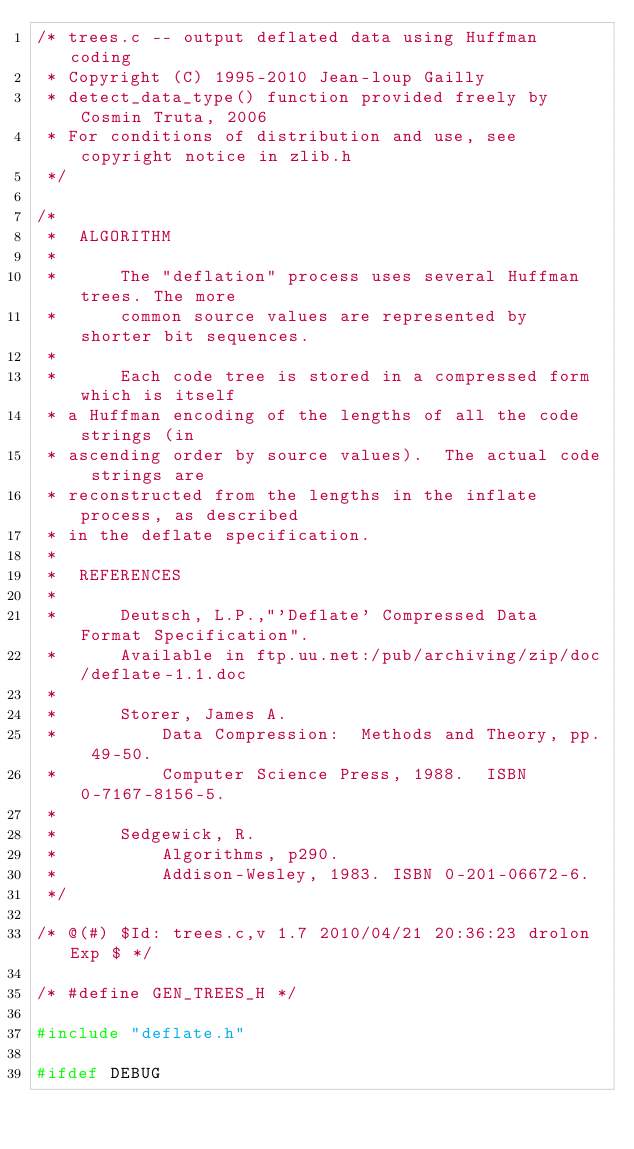<code> <loc_0><loc_0><loc_500><loc_500><_C_>/* trees.c -- output deflated data using Huffman coding
 * Copyright (C) 1995-2010 Jean-loup Gailly
 * detect_data_type() function provided freely by Cosmin Truta, 2006
 * For conditions of distribution and use, see copyright notice in zlib.h
 */

/*
 *  ALGORITHM
 *
 *      The "deflation" process uses several Huffman trees. The more
 *      common source values are represented by shorter bit sequences.
 *
 *      Each code tree is stored in a compressed form which is itself
 * a Huffman encoding of the lengths of all the code strings (in
 * ascending order by source values).  The actual code strings are
 * reconstructed from the lengths in the inflate process, as described
 * in the deflate specification.
 *
 *  REFERENCES
 *
 *      Deutsch, L.P.,"'Deflate' Compressed Data Format Specification".
 *      Available in ftp.uu.net:/pub/archiving/zip/doc/deflate-1.1.doc
 *
 *      Storer, James A.
 *          Data Compression:  Methods and Theory, pp. 49-50.
 *          Computer Science Press, 1988.  ISBN 0-7167-8156-5.
 *
 *      Sedgewick, R.
 *          Algorithms, p290.
 *          Addison-Wesley, 1983. ISBN 0-201-06672-6.
 */

/* @(#) $Id: trees.c,v 1.7 2010/04/21 20:36:23 drolon Exp $ */

/* #define GEN_TREES_H */

#include "deflate.h"

#ifdef DEBUG</code> 